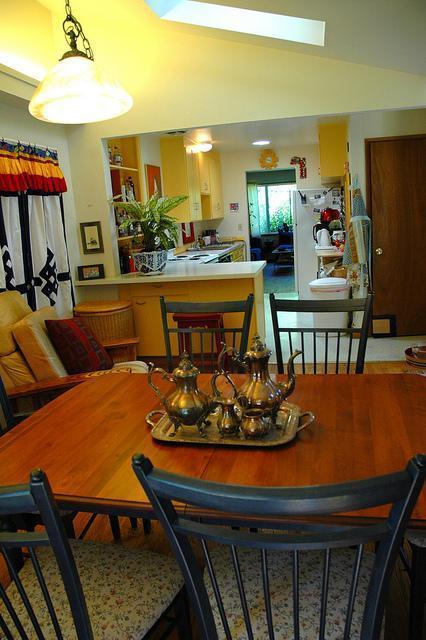How many chairs are visible?
Give a very brief answer. 5. 